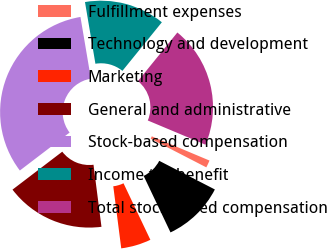Convert chart to OTSL. <chart><loc_0><loc_0><loc_500><loc_500><pie_chart><fcel>Fulfillment expenses<fcel>Technology and development<fcel>Marketing<fcel>General and administrative<fcel>Stock-based compensation<fcel>Income tax benefit<fcel>Total stock-based compensation<nl><fcel>1.24%<fcel>10.37%<fcel>5.03%<fcel>16.66%<fcel>32.7%<fcel>13.52%<fcel>20.47%<nl></chart> 